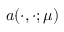Convert formula to latex. <formula><loc_0><loc_0><loc_500><loc_500>a ( \cdot , \cdot ; \mu )</formula> 